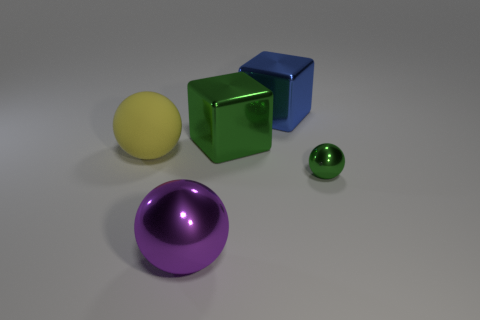Is there any other thing that is the same size as the green metal ball?
Provide a short and direct response. No. Is there any other thing that has the same material as the yellow object?
Your answer should be compact. No. Are any small red metal cubes visible?
Your answer should be compact. No. What number of things are green blocks or balls in front of the matte ball?
Offer a very short reply. 3. Does the ball that is left of the purple metal ball have the same size as the big metal sphere?
Provide a short and direct response. Yes. How many other things are the same size as the purple object?
Ensure brevity in your answer.  3. The matte thing is what color?
Provide a succinct answer. Yellow. There is a big thing behind the large green metallic block; what is it made of?
Your answer should be compact. Metal. Are there an equal number of things that are to the right of the big purple sphere and large metallic things?
Keep it short and to the point. Yes. Is the small thing the same shape as the big green metal object?
Give a very brief answer. No. 